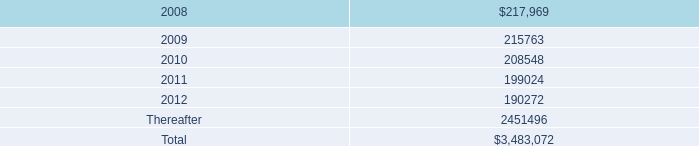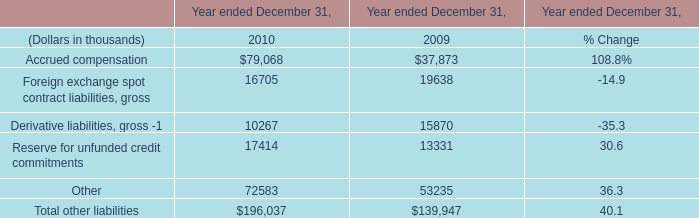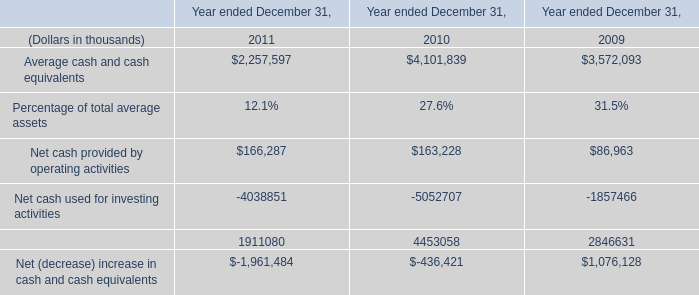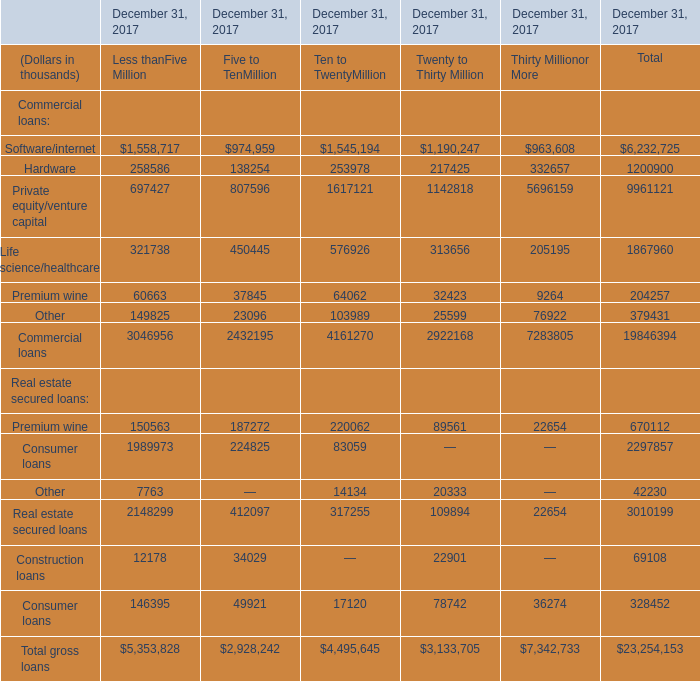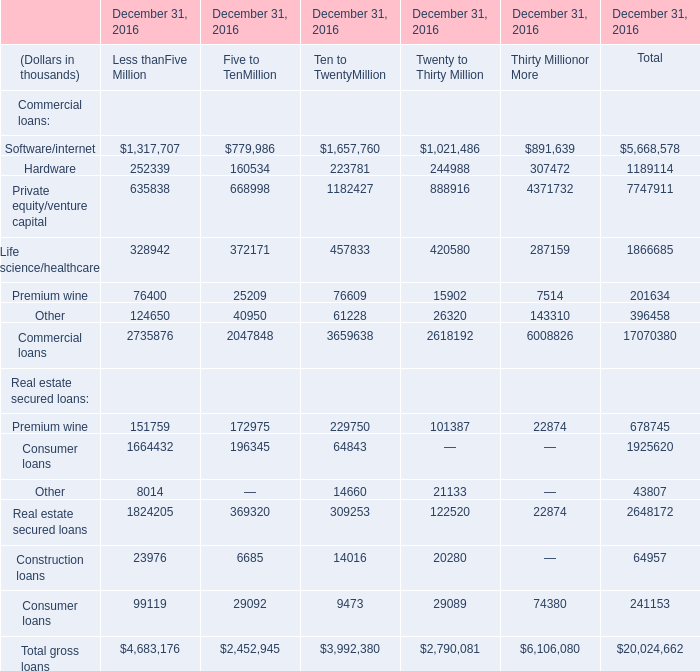What was the total amount of Less thanFive Million in 2016? (in thousand) 
Computations: ((((2735876 + 1824205) + 23976) + 99119) + 4683176)
Answer: 9366352.0. 